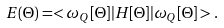<formula> <loc_0><loc_0><loc_500><loc_500>E ( \Theta ) = < \omega _ { Q } [ \Theta ] | H [ \Theta ] | \omega _ { Q } [ \Theta ] > .</formula> 